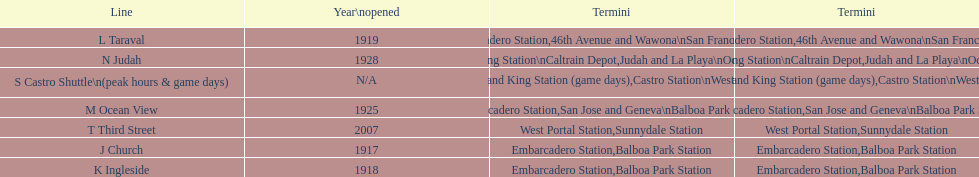Parse the table in full. {'header': ['Line', 'Year\\nopened', 'Termini', 'Termini'], 'rows': [['L Taraval', '1919', 'Embarcadero Station', '46th Avenue and Wawona\\nSan Francisco Zoo'], ['N Judah', '1928', '4th and King Station\\nCaltrain Depot', 'Judah and La Playa\\nOcean Beach'], ['S Castro Shuttle\\n(peak hours & game days)', 'N/A', 'Embarcadero Station\\n4th and King Station\xa0(game days)', 'Castro Station\\nWest Portal Station\xa0(game days)'], ['M Ocean View', '1925', 'Embarcadero Station', 'San Jose and Geneva\\nBalboa Park Station'], ['T Third Street', '2007', 'West Portal Station', 'Sunnydale Station'], ['J Church', '1917', 'Embarcadero Station', 'Balboa Park Station'], ['K Ingleside', '1918', 'Embarcadero Station', 'Balboa Park Station']]} On game days, which line do you want to use? S Castro Shuttle. 